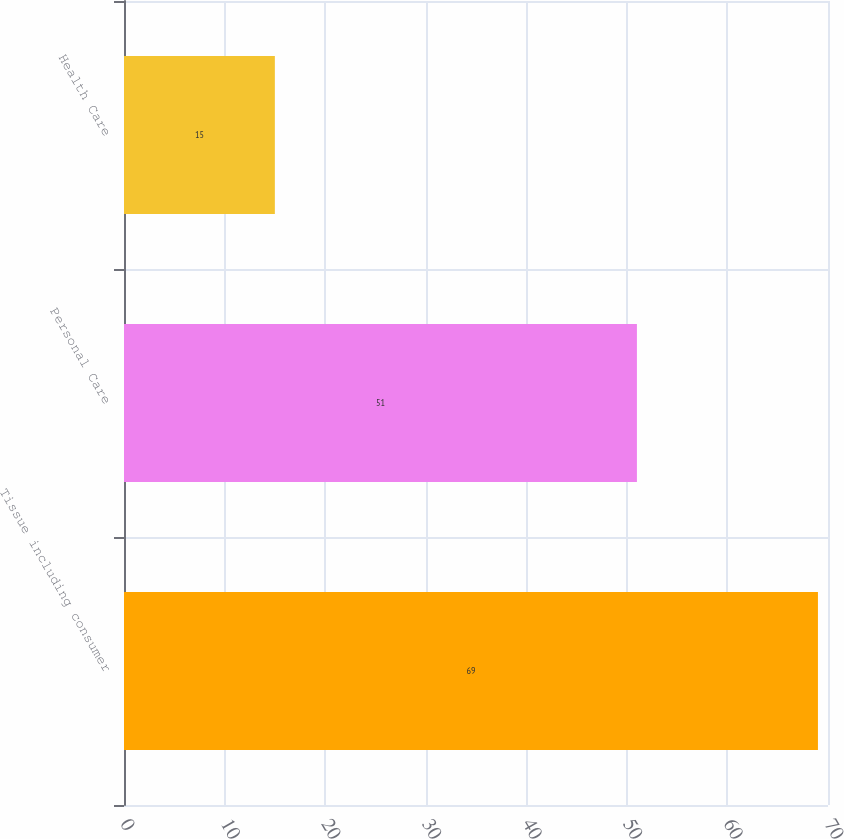<chart> <loc_0><loc_0><loc_500><loc_500><bar_chart><fcel>Tissue including consumer<fcel>Personal Care<fcel>Health Care<nl><fcel>69<fcel>51<fcel>15<nl></chart> 